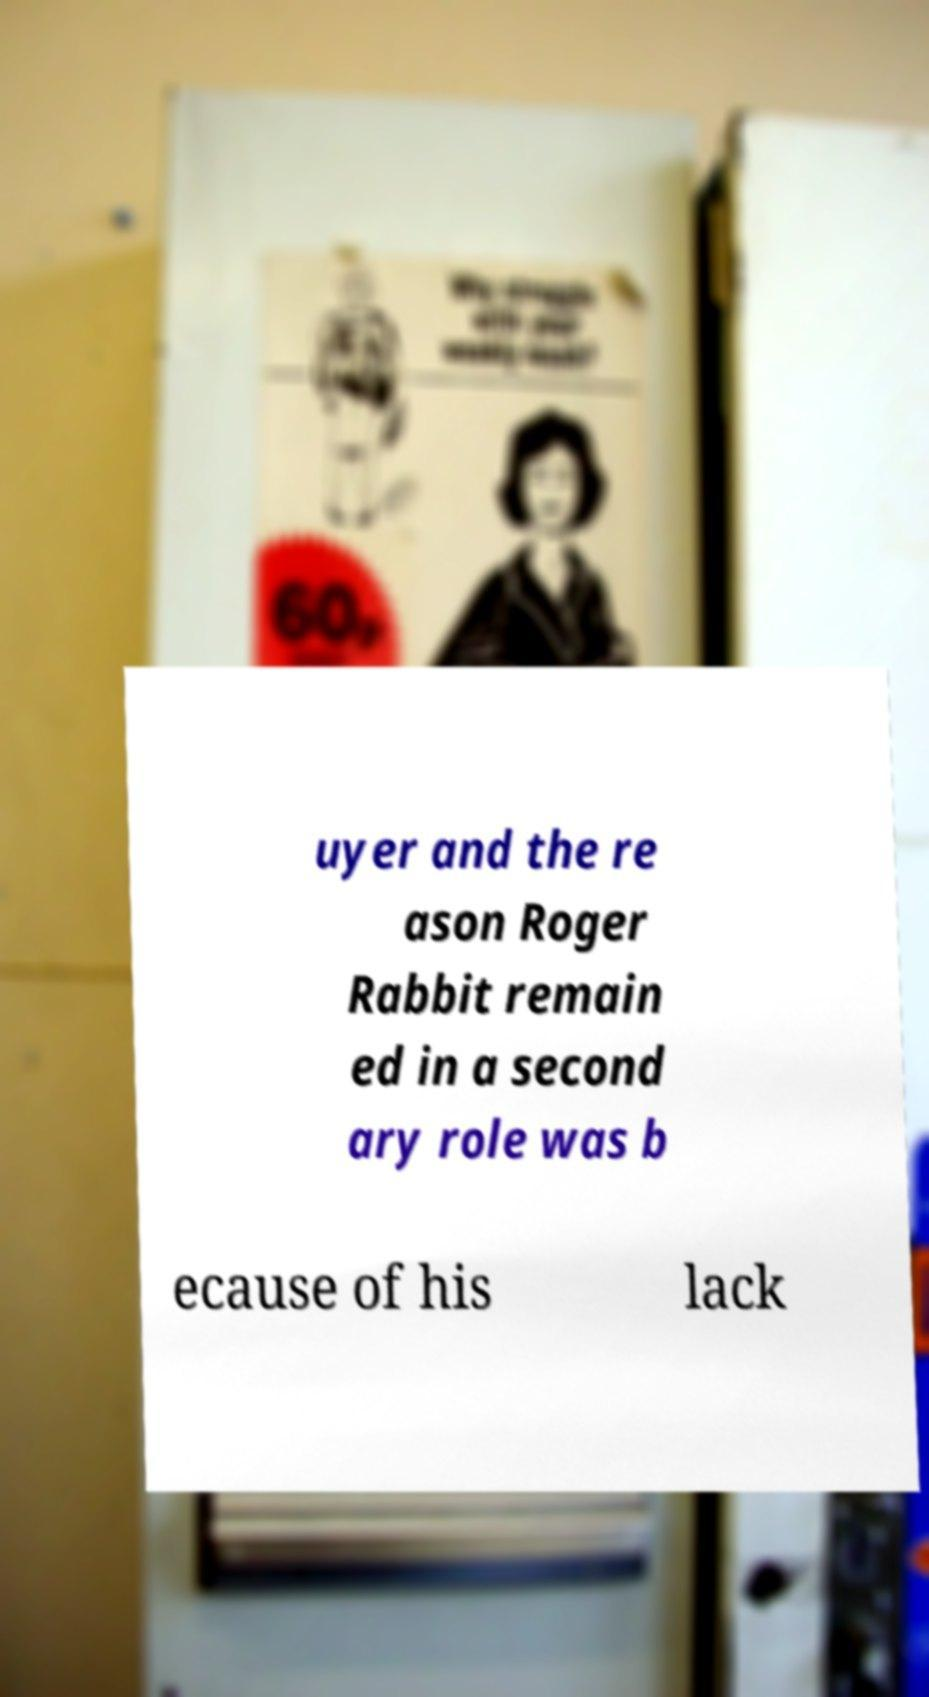For documentation purposes, I need the text within this image transcribed. Could you provide that? uyer and the re ason Roger Rabbit remain ed in a second ary role was b ecause of his lack 